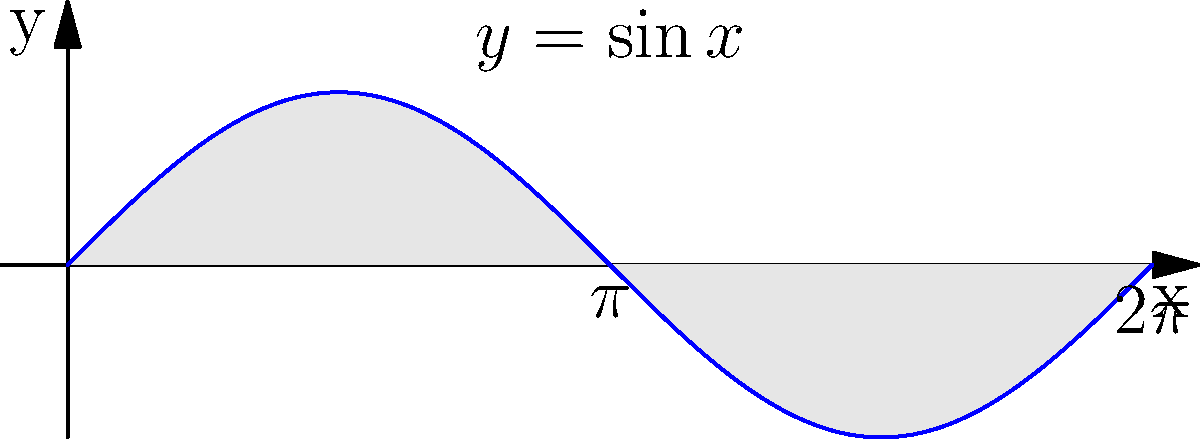As a crossword enthusiast who appreciates creative layouts, you encounter a calculus-themed puzzle. One clue asks for the area under the sine curve over one complete period, as shown in the shaded region of the graph. What is this area? To find the area under the sine curve over one period, we need to integrate the function $f(x) = \sin x$ from 0 to $2\pi$. Let's break this down step-by-step:

1) The integral we need to evaluate is:
   $$\int_0^{2\pi} \sin x \, dx$$

2) We know that the antiderivative of $\sin x$ is $-\cos x + C$. So, we can apply the Fundamental Theorem of Calculus:
   $$[-\cos x]_0^{2\pi}$$

3) This means we need to calculate:
   $$(-\cos(2\pi)) - (-\cos(0))$$

4) We know that:
   $\cos(2\pi) = 1$
   $\cos(0) = 1$

5) Substituting these values:
   $$(-1) - (-1) = -1 + 1 = 0$$

6) Therefore, the area under the sine curve over one complete period is 0.

This result might seem counterintuitive at first, but it makes sense when you consider that the positive area above the x-axis in the first half of the period is exactly balanced by the negative area below the x-axis in the second half of the period.
Answer: 0 